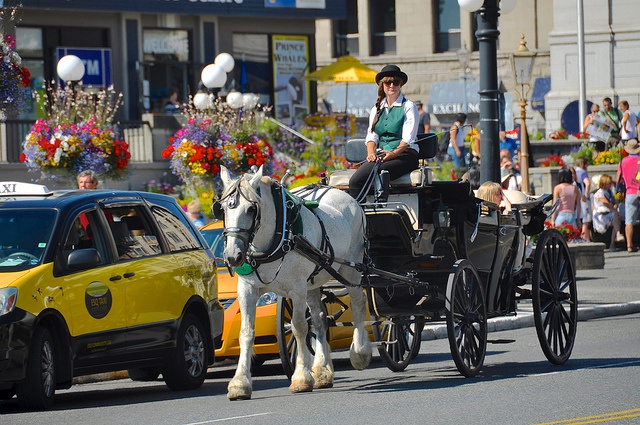Describe the objects in this image and their specific colors. I can see car in gray, black, and olive tones, horse in gray, black, darkgray, and ivory tones, potted plant in gray, darkgray, olive, and black tones, car in gray, black, olive, and orange tones, and people in gray, black, white, and teal tones in this image. 